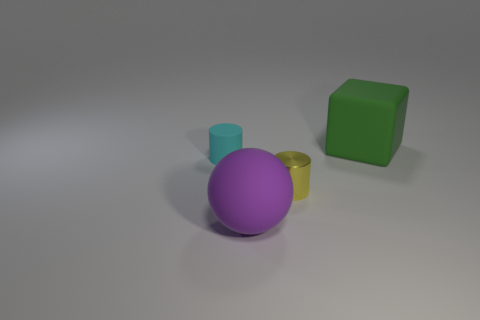Subtract all cyan cylinders. How many cylinders are left? 1 Subtract all spheres. How many objects are left? 3 Subtract 1 cylinders. How many cylinders are left? 1 Add 3 yellow cylinders. How many objects exist? 7 Add 3 matte balls. How many matte balls exist? 4 Subtract 0 blue spheres. How many objects are left? 4 Subtract all yellow spheres. Subtract all gray cylinders. How many spheres are left? 1 Subtract all big brown cylinders. Subtract all large rubber blocks. How many objects are left? 3 Add 4 matte cubes. How many matte cubes are left? 5 